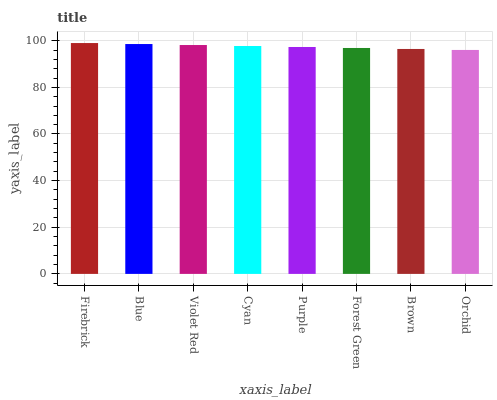Is Orchid the minimum?
Answer yes or no. Yes. Is Firebrick the maximum?
Answer yes or no. Yes. Is Blue the minimum?
Answer yes or no. No. Is Blue the maximum?
Answer yes or no. No. Is Firebrick greater than Blue?
Answer yes or no. Yes. Is Blue less than Firebrick?
Answer yes or no. Yes. Is Blue greater than Firebrick?
Answer yes or no. No. Is Firebrick less than Blue?
Answer yes or no. No. Is Cyan the high median?
Answer yes or no. Yes. Is Purple the low median?
Answer yes or no. Yes. Is Orchid the high median?
Answer yes or no. No. Is Firebrick the low median?
Answer yes or no. No. 